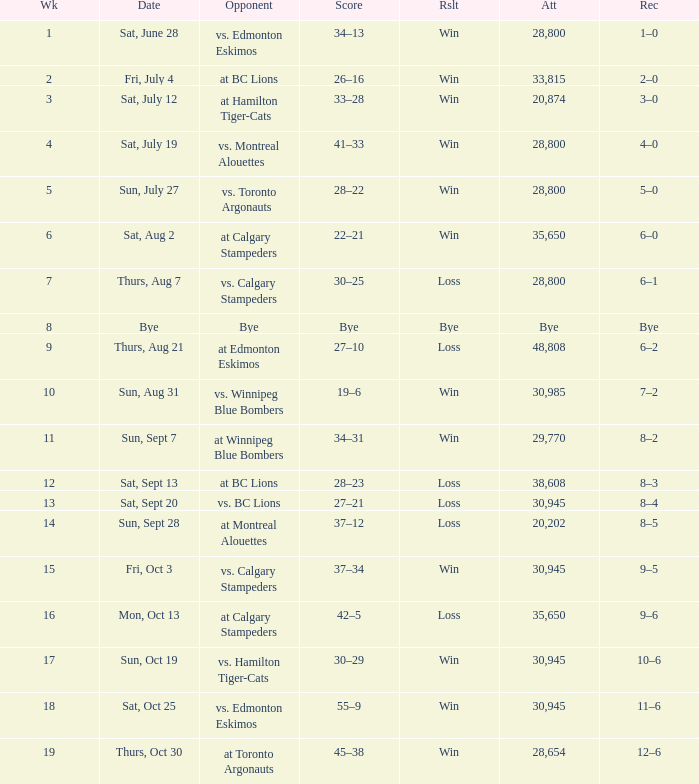What was the record the the match against vs. calgary stampeders before week 15? 6–1. 